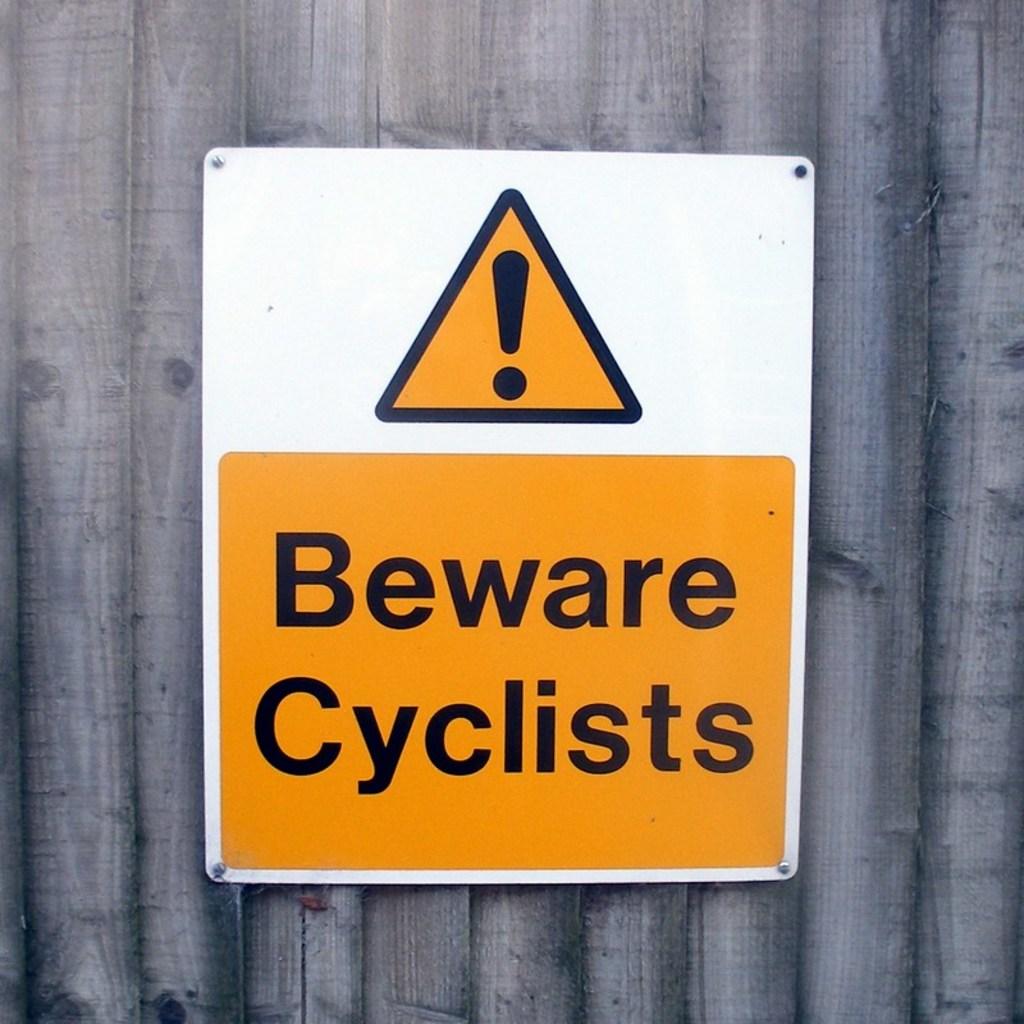Who is the sign trying to protect?
Your response must be concise. Cyclists. 